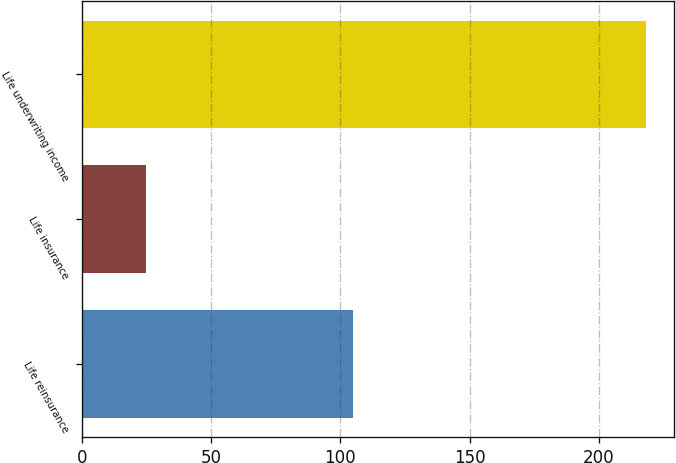Convert chart to OTSL. <chart><loc_0><loc_0><loc_500><loc_500><bar_chart><fcel>Life reinsurance<fcel>Life insurance<fcel>Life underwriting income<nl><fcel>105<fcel>25<fcel>218<nl></chart> 